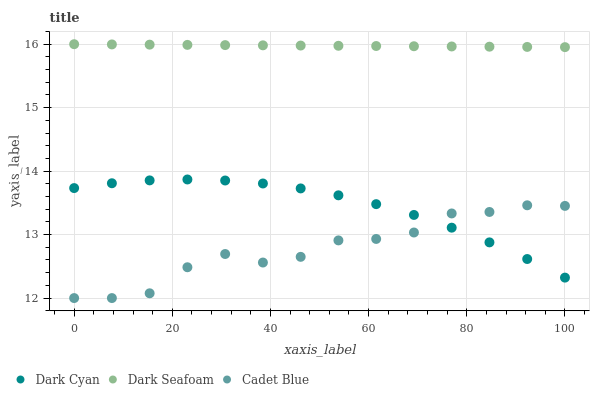Does Cadet Blue have the minimum area under the curve?
Answer yes or no. Yes. Does Dark Seafoam have the maximum area under the curve?
Answer yes or no. Yes. Does Dark Seafoam have the minimum area under the curve?
Answer yes or no. No. Does Cadet Blue have the maximum area under the curve?
Answer yes or no. No. Is Dark Seafoam the smoothest?
Answer yes or no. Yes. Is Cadet Blue the roughest?
Answer yes or no. Yes. Is Cadet Blue the smoothest?
Answer yes or no. No. Is Dark Seafoam the roughest?
Answer yes or no. No. Does Cadet Blue have the lowest value?
Answer yes or no. Yes. Does Dark Seafoam have the lowest value?
Answer yes or no. No. Does Dark Seafoam have the highest value?
Answer yes or no. Yes. Does Cadet Blue have the highest value?
Answer yes or no. No. Is Cadet Blue less than Dark Seafoam?
Answer yes or no. Yes. Is Dark Seafoam greater than Cadet Blue?
Answer yes or no. Yes. Does Cadet Blue intersect Dark Cyan?
Answer yes or no. Yes. Is Cadet Blue less than Dark Cyan?
Answer yes or no. No. Is Cadet Blue greater than Dark Cyan?
Answer yes or no. No. Does Cadet Blue intersect Dark Seafoam?
Answer yes or no. No. 